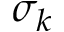<formula> <loc_0><loc_0><loc_500><loc_500>\sigma _ { k }</formula> 